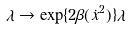Convert formula to latex. <formula><loc_0><loc_0><loc_500><loc_500>\lambda \rightarrow \exp \{ 2 \beta ( \dot { x } ^ { 2 } ) \} \lambda</formula> 